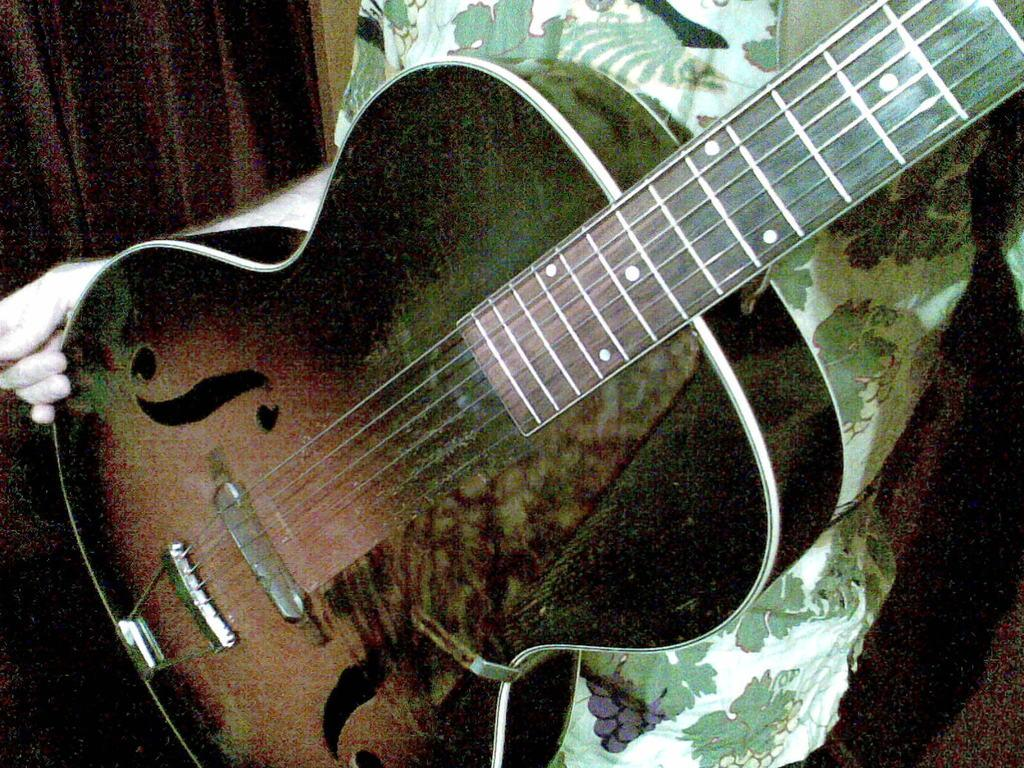Who or what is the main subject in the image? There is a person in the center of the image. What is the person holding in the image? The person is holding a guitar. What can be seen in the background of the image? There is a curtain in the background of the image. What type of yarn is the person using to play the guitar in the image? There is no yarn present in the image, and the person is not using any yarn to play the guitar. 